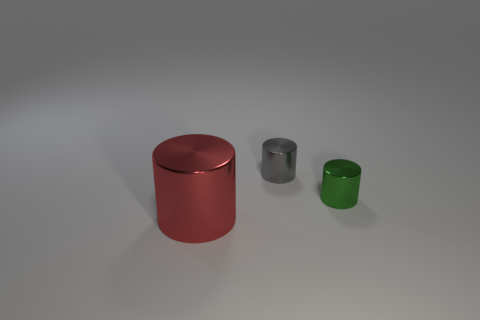Subtract all large red cylinders. How many cylinders are left? 2 Subtract all green cylinders. How many cylinders are left? 2 Subtract 2 cylinders. How many cylinders are left? 1 Add 3 gray metallic objects. How many objects exist? 6 Subtract all blue cylinders. Subtract all purple cubes. How many cylinders are left? 3 Subtract all gray cubes. How many yellow cylinders are left? 0 Subtract all large yellow shiny cubes. Subtract all tiny gray metallic things. How many objects are left? 2 Add 3 red metal objects. How many red metal objects are left? 4 Add 2 tiny red matte cylinders. How many tiny red matte cylinders exist? 2 Subtract 0 purple balls. How many objects are left? 3 